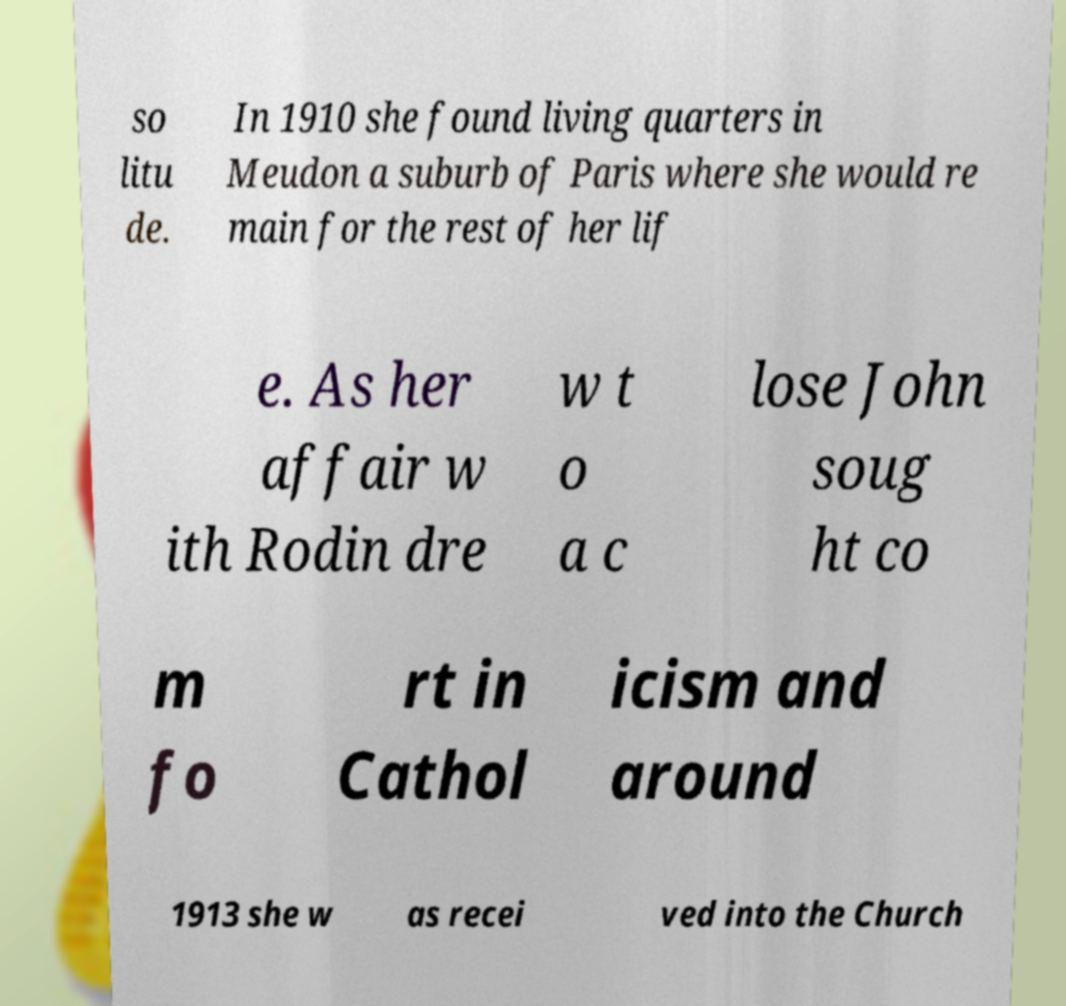I need the written content from this picture converted into text. Can you do that? so litu de. In 1910 she found living quarters in Meudon a suburb of Paris where she would re main for the rest of her lif e. As her affair w ith Rodin dre w t o a c lose John soug ht co m fo rt in Cathol icism and around 1913 she w as recei ved into the Church 